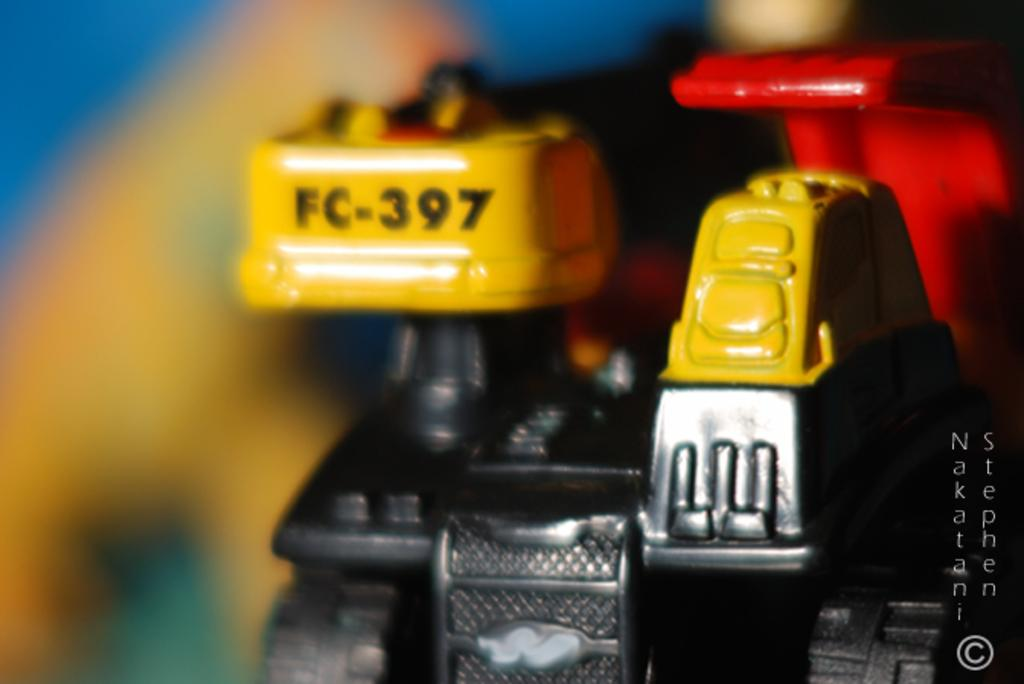<image>
Offer a succinct explanation of the picture presented. The yellow mechanical part is labeled number FC-397. 